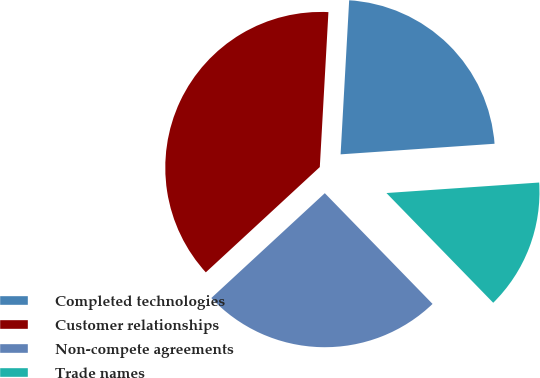Convert chart to OTSL. <chart><loc_0><loc_0><loc_500><loc_500><pie_chart><fcel>Completed technologies<fcel>Customer relationships<fcel>Non-compete agreements<fcel>Trade names<nl><fcel>23.02%<fcel>37.75%<fcel>25.41%<fcel>13.81%<nl></chart> 